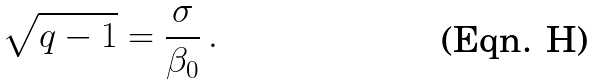Convert formula to latex. <formula><loc_0><loc_0><loc_500><loc_500>\sqrt { q - 1 } = \frac { \sigma } { \beta _ { 0 } } \, .</formula> 